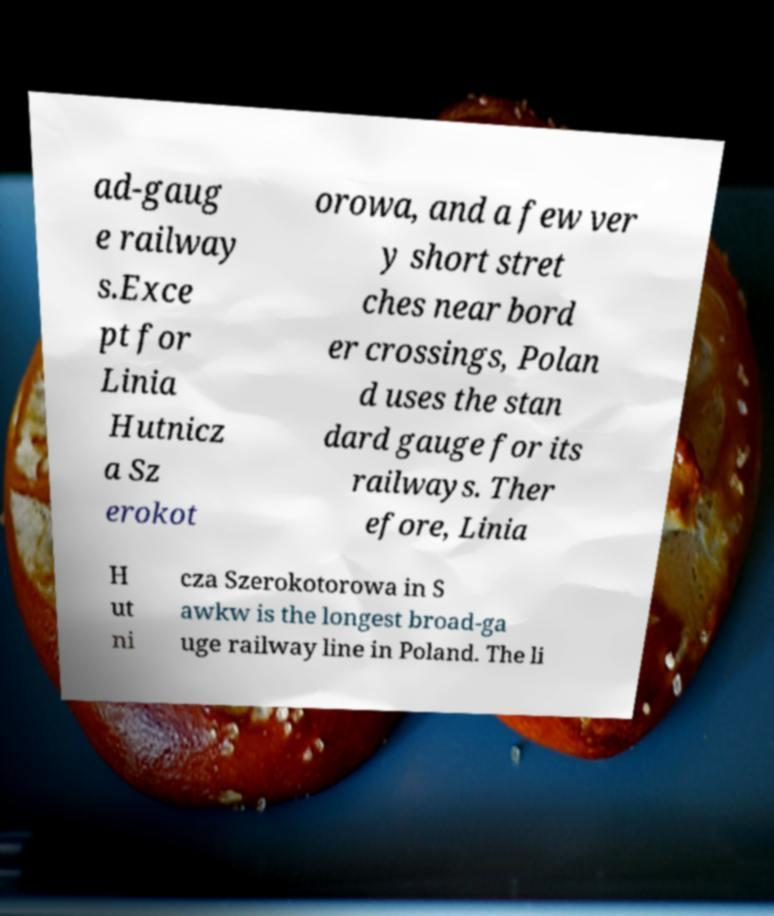Can you accurately transcribe the text from the provided image for me? ad-gaug e railway s.Exce pt for Linia Hutnicz a Sz erokot orowa, and a few ver y short stret ches near bord er crossings, Polan d uses the stan dard gauge for its railways. Ther efore, Linia H ut ni cza Szerokotorowa in S awkw is the longest broad-ga uge railway line in Poland. The li 